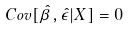<formula> <loc_0><loc_0><loc_500><loc_500>C o v [ \hat { \beta } , \hat { \epsilon } | X ] = 0</formula> 